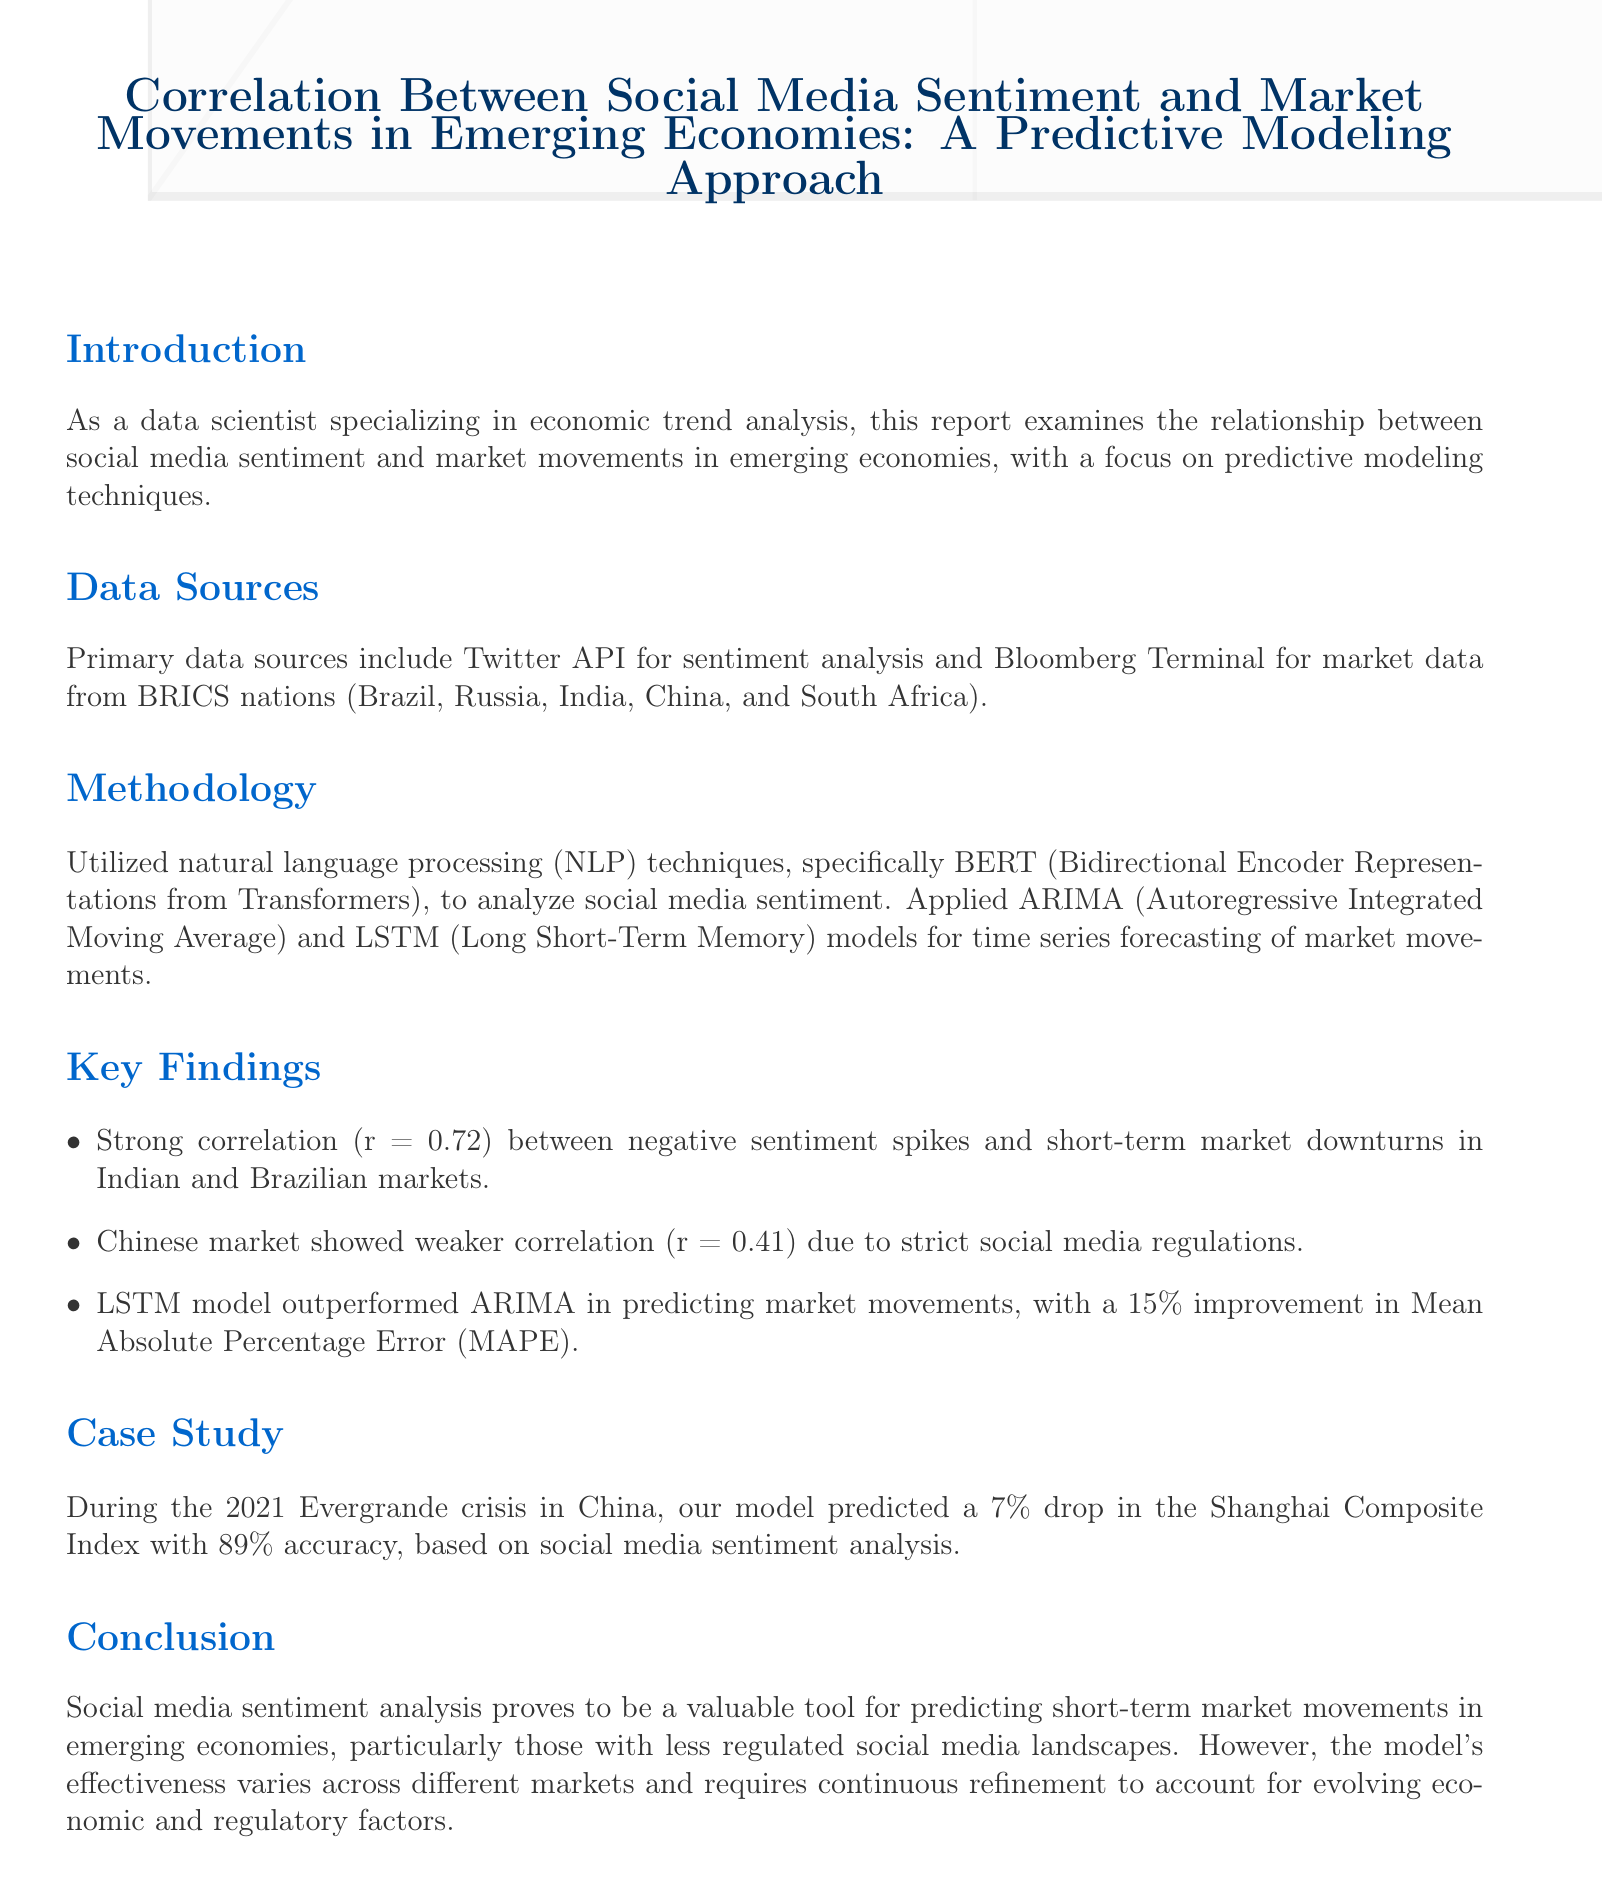what are the primary data sources used in the analysis? The primary data sources include Twitter API for sentiment analysis and Bloomberg Terminal for market data from BRICS nations.
Answer: Twitter API and Bloomberg Terminal what correlation coefficient is reported for the Indian and Brazilian markets? The correlation coefficient reported for the Indian and Brazilian markets is a strong correlation of 0.72 between negative sentiment spikes and short-term market downturns.
Answer: 0.72 which predictive model outperformed the ARIMA model? The model that outperformed the ARIMA model is the LSTM.
Answer: LSTM in which year was the Evergrande crisis that served as a case study? The year of the Evergrande crisis mentioned in the case study is 2021.
Answer: 2021 what percentage improvement did the LSTM model achieve in Mean Absolute Percentage Error? The LSTM model achieved a 15 percent improvement in Mean Absolute Percentage Error.
Answer: 15% why did the Chinese market show a weaker correlation? The Chinese market showed a weaker correlation due to strict social media regulations.
Answer: strict social media regulations what was the predicted drop in the Shanghai Composite Index during the Evergrande crisis? The predicted drop in the Shanghai Composite Index during the Evergrande crisis was 7 percent.
Answer: 7% what is the document's main focus or theme? The main focus of the document is the examination of the relationship between social media sentiment and market movements.
Answer: examination of the relationship between social media sentiment and market movements which country showed the strongest correlation according to the key findings? According to the key findings, India showed the strongest correlation.
Answer: India 